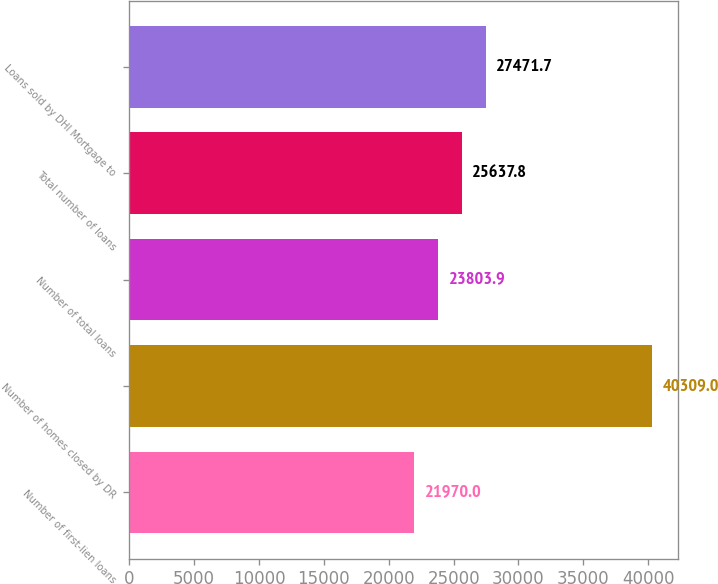Convert chart. <chart><loc_0><loc_0><loc_500><loc_500><bar_chart><fcel>Number of first-lien loans<fcel>Number of homes closed by DR<fcel>Number of total loans<fcel>Total number of loans<fcel>Loans sold by DHI Mortgage to<nl><fcel>21970<fcel>40309<fcel>23803.9<fcel>25637.8<fcel>27471.7<nl></chart> 